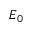Convert formula to latex. <formula><loc_0><loc_0><loc_500><loc_500>E _ { 0 }</formula> 